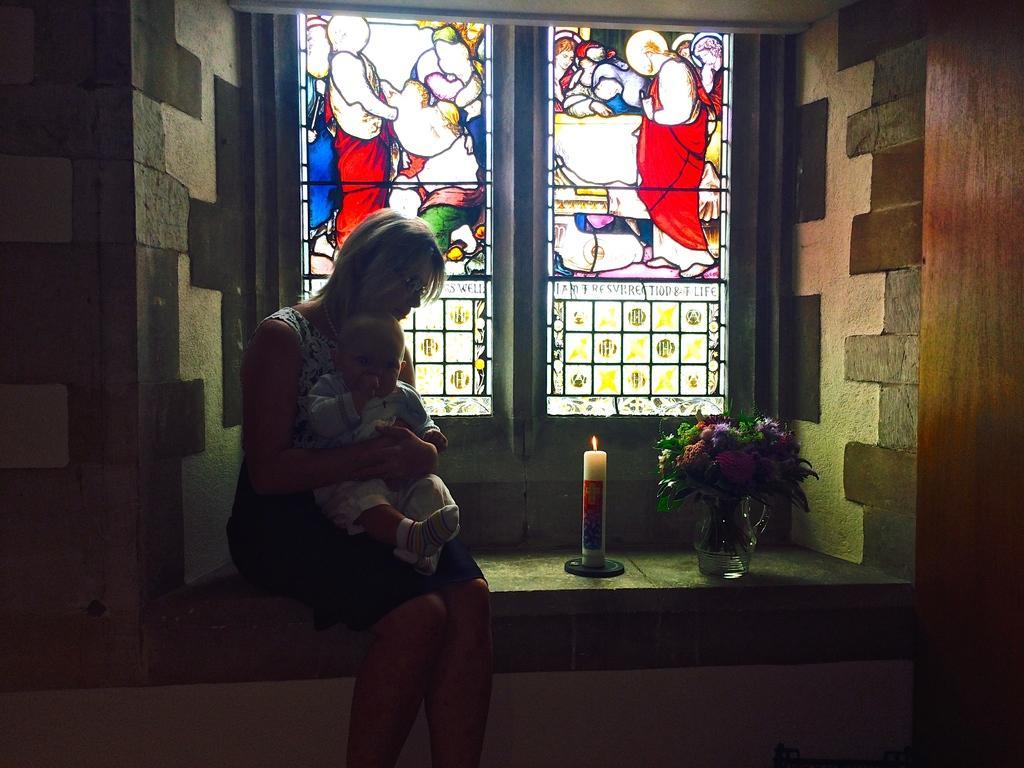In one or two sentences, can you explain what this image depicts? Here we can see a woman sitting on a platform by holding a kid in her hands at the window and there is a candle with flame and a flower vase on this platform. On the window we can see designs and this is the wall. 